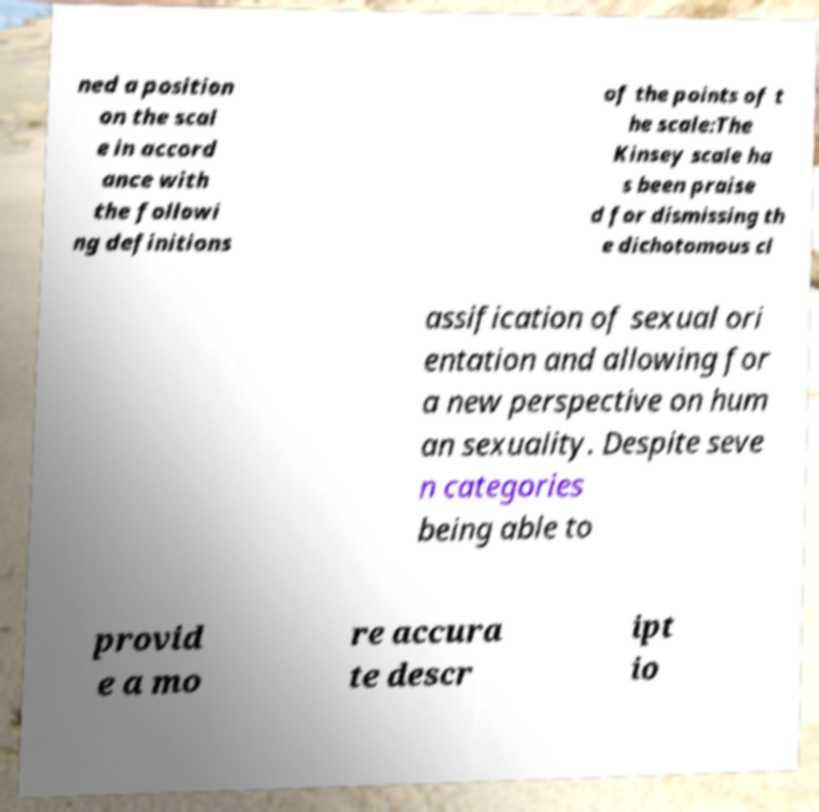Please identify and transcribe the text found in this image. ned a position on the scal e in accord ance with the followi ng definitions of the points of t he scale:The Kinsey scale ha s been praise d for dismissing th e dichotomous cl assification of sexual ori entation and allowing for a new perspective on hum an sexuality. Despite seve n categories being able to provid e a mo re accura te descr ipt io 